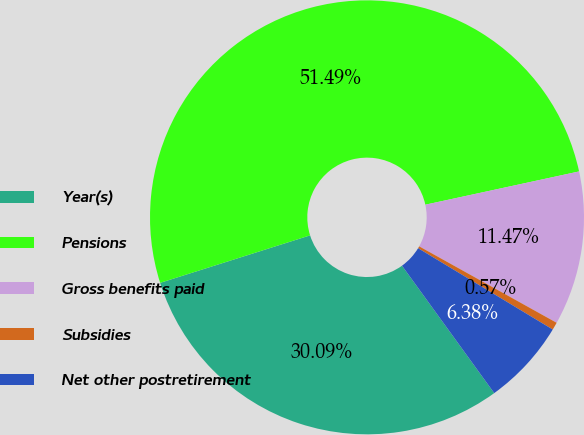Convert chart to OTSL. <chart><loc_0><loc_0><loc_500><loc_500><pie_chart><fcel>Year(s)<fcel>Pensions<fcel>Gross benefits paid<fcel>Subsidies<fcel>Net other postretirement<nl><fcel>30.09%<fcel>51.49%<fcel>11.47%<fcel>0.57%<fcel>6.38%<nl></chart> 